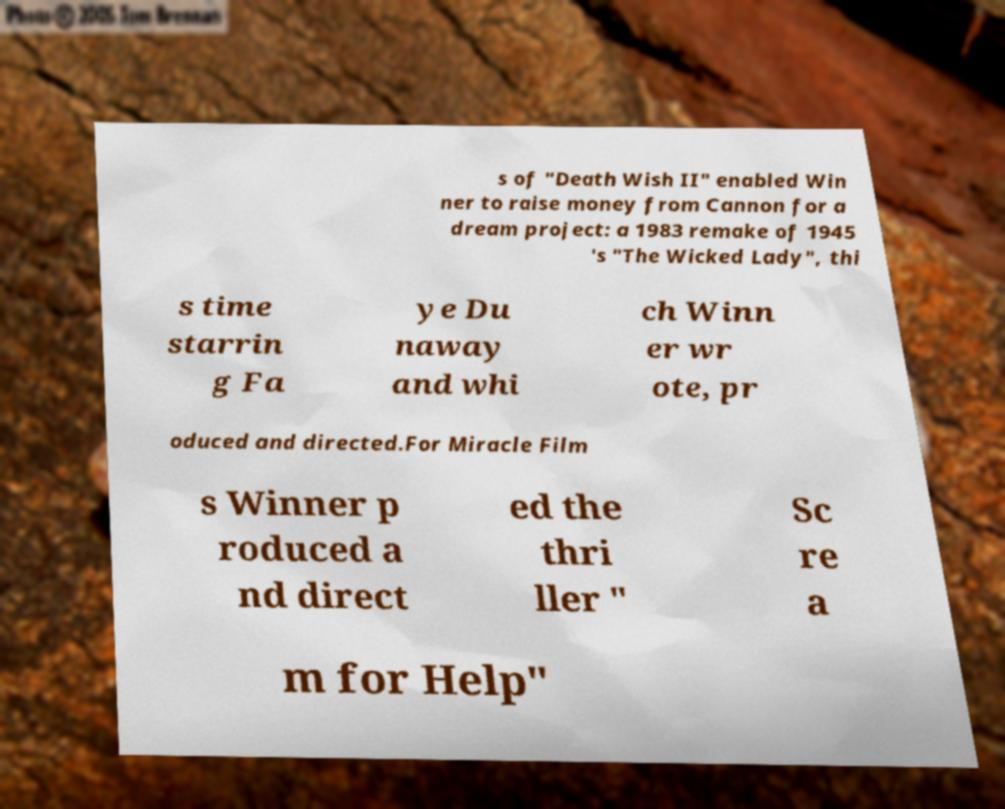Please identify and transcribe the text found in this image. s of "Death Wish II" enabled Win ner to raise money from Cannon for a dream project: a 1983 remake of 1945 's "The Wicked Lady", thi s time starrin g Fa ye Du naway and whi ch Winn er wr ote, pr oduced and directed.For Miracle Film s Winner p roduced a nd direct ed the thri ller " Sc re a m for Help" 